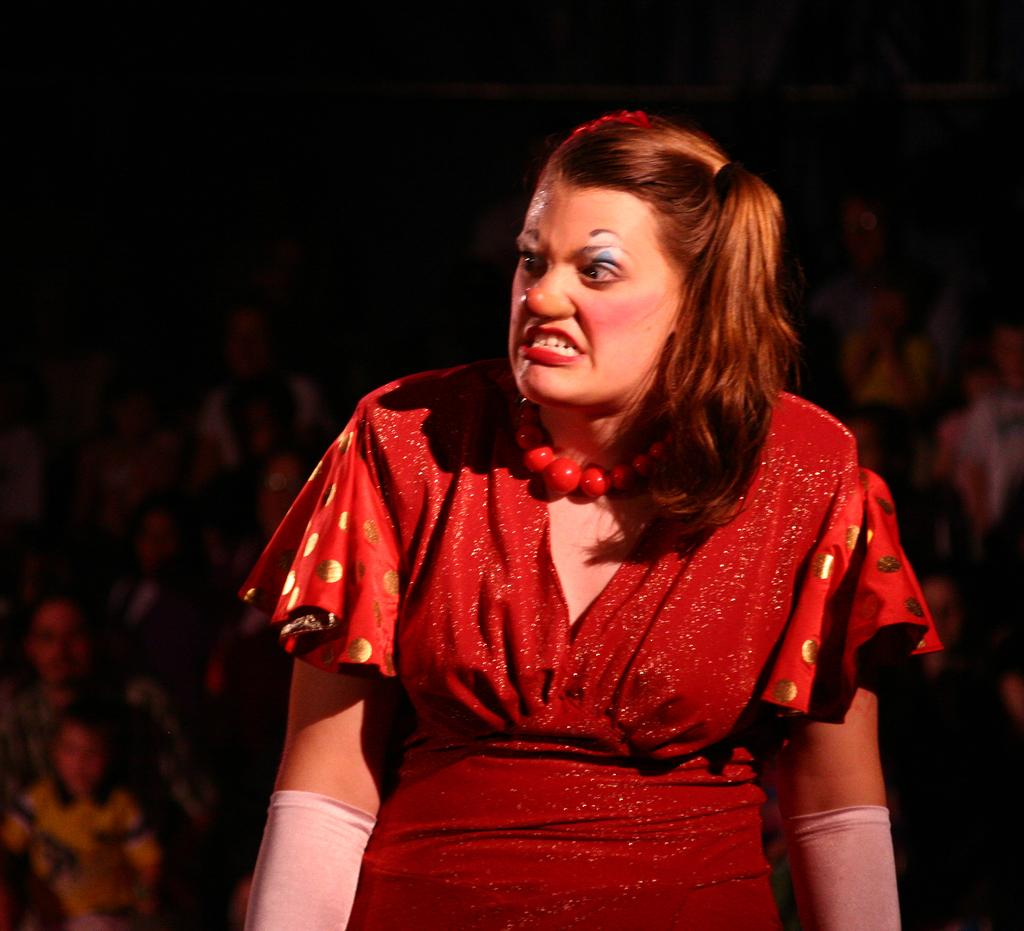Who is present in the image? There is a woman in the image. Can you describe the group of people in the image? There is a group of people sitting in the image. How many nuts are being held by the babies in the image? There are no babies present in the image, so there are no nuts being held by them. 